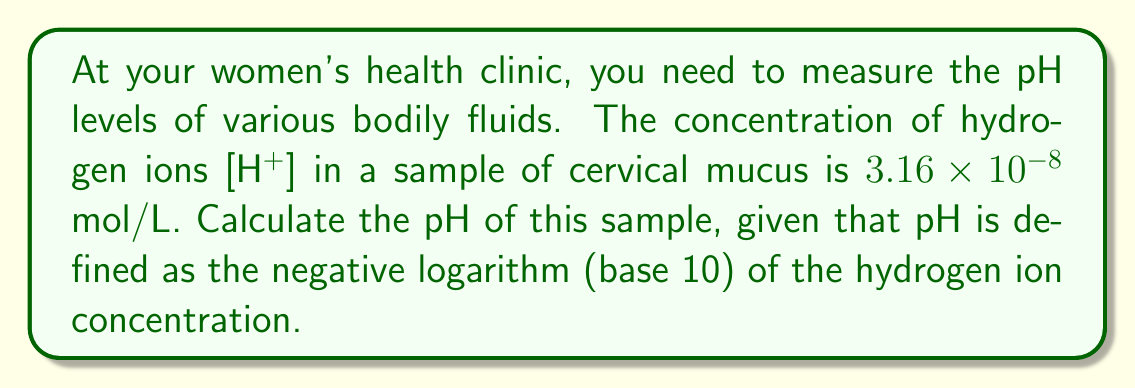Show me your answer to this math problem. To solve this problem, we'll use the definition of pH and the properties of logarithms:

1) The pH is defined as:
   $$\text{pH} = -\log_{10}[\text{H}^+]$$

2) We're given that $[\text{H}^+] = 3.16 \times 10^{-8}$ mol/L

3) Substituting this into the pH equation:
   $$\text{pH} = -\log_{10}(3.16 \times 10^{-8})$$

4) Using the properties of logarithms, we can split this into two parts:
   $$\text{pH} = -(\log_{10}(3.16) + \log_{10}(10^{-8}))$$

5) Simplify:
   $$\text{pH} = -(\log_{10}(3.16) - 8)$$

6) Calculate $\log_{10}(3.16)$ (you can use a calculator for this):
   $$\log_{10}(3.16) \approx 0.4997$$

7) Substitute this back in:
   $$\text{pH} = -(0.4997 - 8) = -0.4997 + 8 = 7.5003$$

8) Rounding to two decimal places (which is typically sufficient for pH measurements):
   $$\text{pH} \approx 7.50$$
Answer: The pH of the cervical mucus sample is approximately 7.50. 